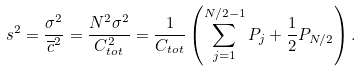<formula> <loc_0><loc_0><loc_500><loc_500>s ^ { 2 } = \frac { \sigma ^ { 2 } } { \overline { c } ^ { 2 } } = \frac { N ^ { 2 } \sigma ^ { 2 } } { C _ { t o t } ^ { 2 } } = \frac { 1 } { C _ { t o t } } \left ( \sum _ { j = 1 } ^ { N / 2 - 1 } P _ { j } + \frac { 1 } { 2 } P _ { N / 2 } \right ) .</formula> 